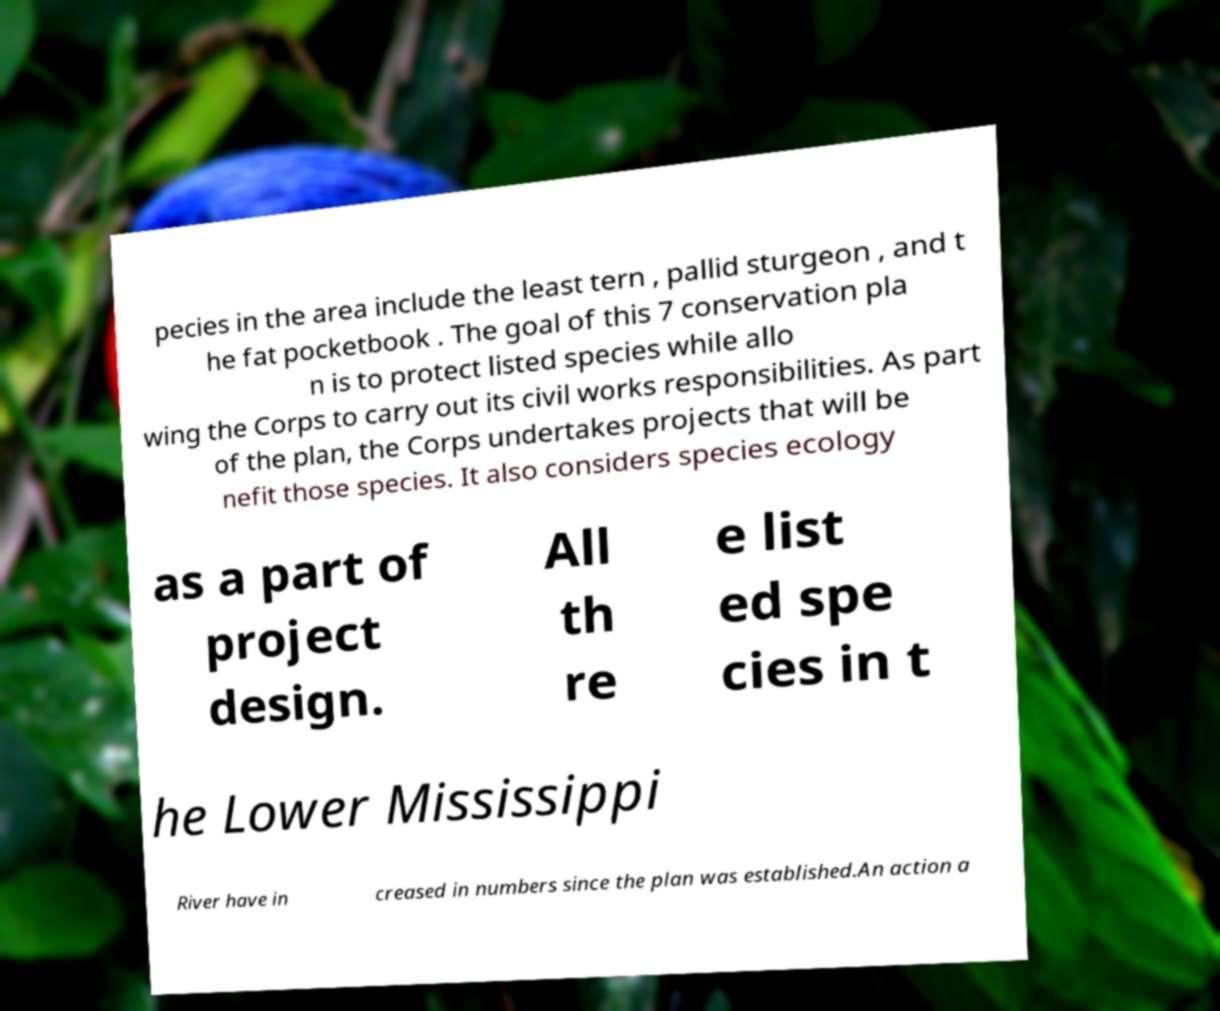I need the written content from this picture converted into text. Can you do that? pecies in the area include the least tern , pallid sturgeon , and t he fat pocketbook . The goal of this 7 conservation pla n is to protect listed species while allo wing the Corps to carry out its civil works responsibilities. As part of the plan, the Corps undertakes projects that will be nefit those species. It also considers species ecology as a part of project design. All th re e list ed spe cies in t he Lower Mississippi River have in creased in numbers since the plan was established.An action a 